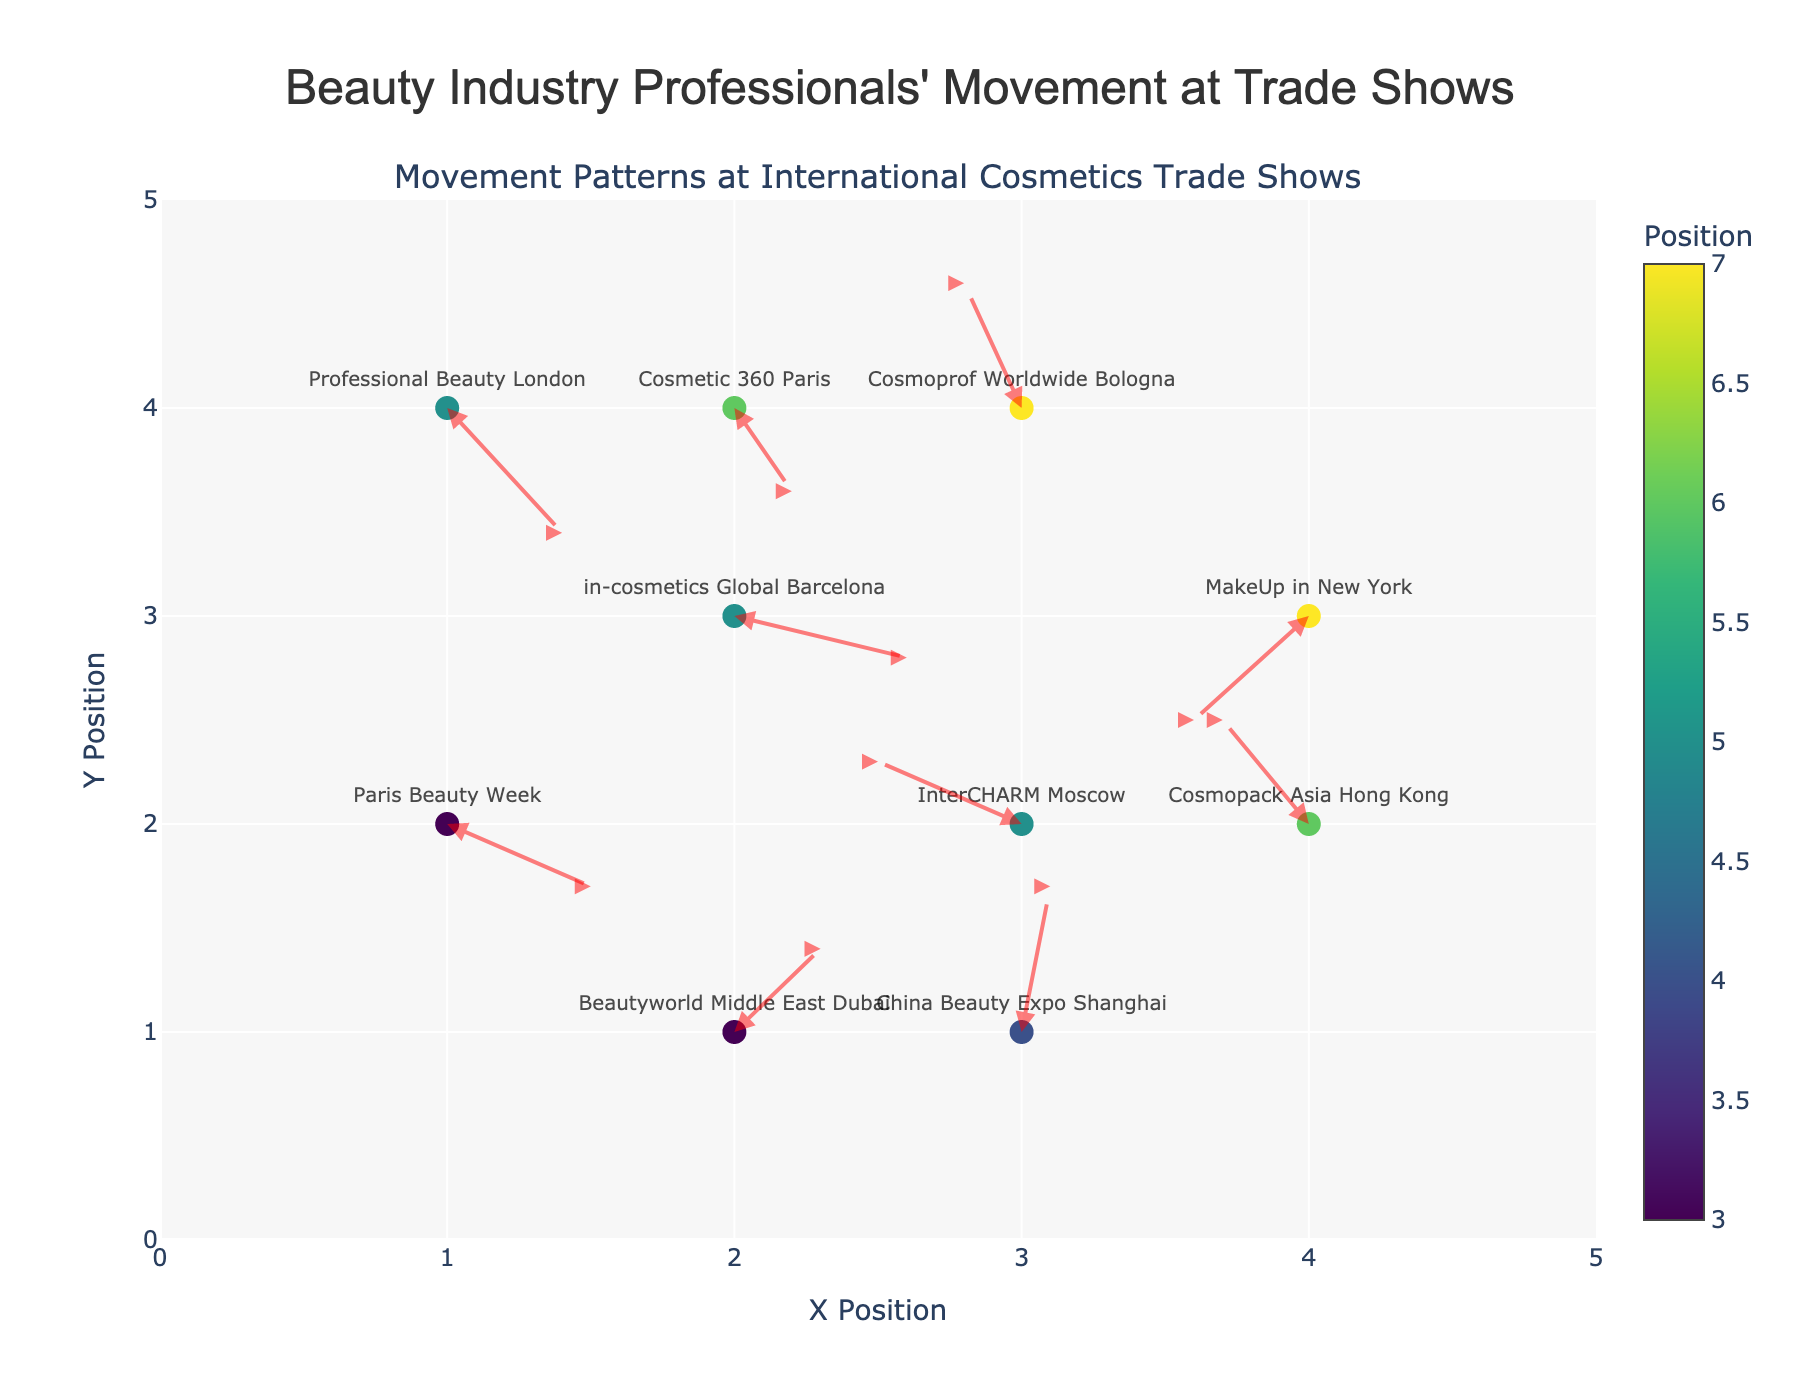How many different locations are represented in the plot? There are markers for 10 different locations as shown by the text labels in the plot.
Answer: 10 What is the title of the plot? The title is located at the top of the plot and reads "Beauty Industry Professionals' Movement at Trade Shows".
Answer: Beauty Industry Professionals' Movement at Trade Shows Which trade show had the largest movement in the y-direction? "China Beauty Expo Shanghai" had the largest change in the y-direction, moving from y=1 to y=1.7 (a change of 0.7).
Answer: China Beauty Expo Shanghai What color represents the position on the plot? The color of the markers, using the Viridis color scale, represents the combined x and y positions of the data points.
Answer: Viridis color scale Which locations have their marker arrows pointing downwards? The locations where arrows point downwards have negative changes in the y-direction. These are "Paris Beauty Week", "Professional Beauty London", and "Cosmetic 360 Paris".
Answer: Paris Beauty Week, Professional Beauty London, Cosmetic 360 Paris What is the average x-coordinate of all markers? The sum of the x-coordinates (1+3+2+4+3+2+4+1+3+2) is 25. Dividing by 10 (number of points) gives an average of 2.5.
Answer: 2.5 Which location has the smallest movement vector in total? The movement vector magnitude is calculated as √(u² + v²) for each location. "Paris Beauty Week" has the smallest movement vector: √(0.5² + (-0.3)²) = √(0.34).
Answer: Paris Beauty Week Which trade shows have an initial position in the third quadrant (x < 3 and y < 3)? These are trade shows with x and y coordinates both less than 3. They are "Paris Beauty Week" (1, 2) and "Beautyworld Middle East Dubai" (2, 1).
Answer: Paris Beauty Week, Beautyworld Middle East Dubai Identify the trade show with its movement vector pointing to the top right. The movement vector pointing to the top right means both u and v are positive. "China Beauty Expo Shanghai" (0.1, 0.7) fits this criterion.
Answer: China Beauty Expo Shanghai Compare the movement direction of "Cosmopack Asia Hong Kong" and "in-cosmetics Global Barcelona". Which one has a negative u-value? "Cosmopack Asia Hong Kong" has a negative u-value (-0.3), while "in-cosmetics Global Barcelona" has a positive u-value (0.6).
Answer: Cosmopack Asia Hong Kong 